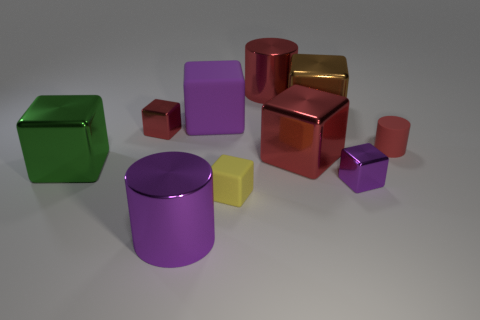What number of things are either large purple blocks or tiny objects that are behind the tiny purple metallic thing?
Your answer should be compact. 3. There is a cylinder that is in front of the small red metal cube and left of the small red rubber object; what color is it?
Your answer should be very brief. Purple. Do the brown shiny block and the yellow rubber block have the same size?
Make the answer very short. No. There is a big cylinder that is in front of the small matte cube; what color is it?
Your response must be concise. Purple. Are there any small rubber cylinders that have the same color as the tiny matte cube?
Give a very brief answer. No. The rubber cube that is the same size as the green metal cube is what color?
Your answer should be very brief. Purple. Is the shape of the small red shiny thing the same as the tiny yellow object?
Offer a terse response. Yes. There is a object that is to the right of the purple shiny cube; what is it made of?
Keep it short and to the point. Rubber. What color is the small rubber block?
Provide a short and direct response. Yellow. There is a purple shiny thing that is on the right side of the large red metal cylinder; is its size the same as the purple matte object that is behind the large purple metal cylinder?
Your response must be concise. No. 